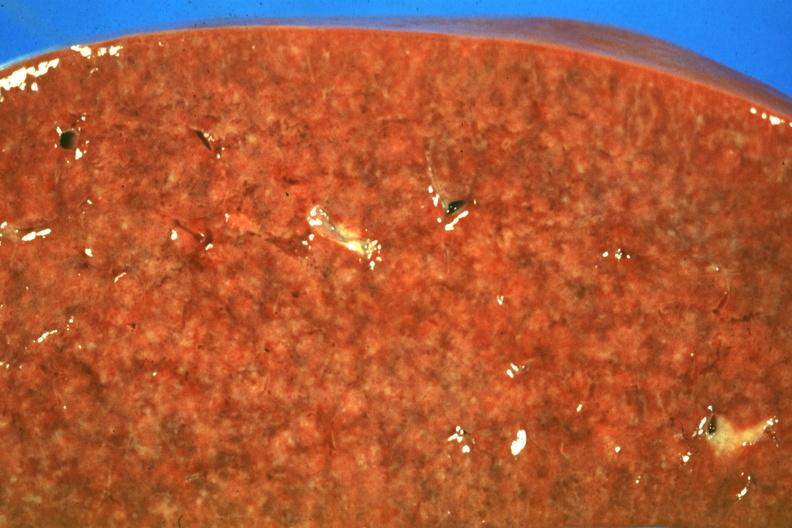what is present?
Answer the question using a single word or phrase. Sarcoidosis 